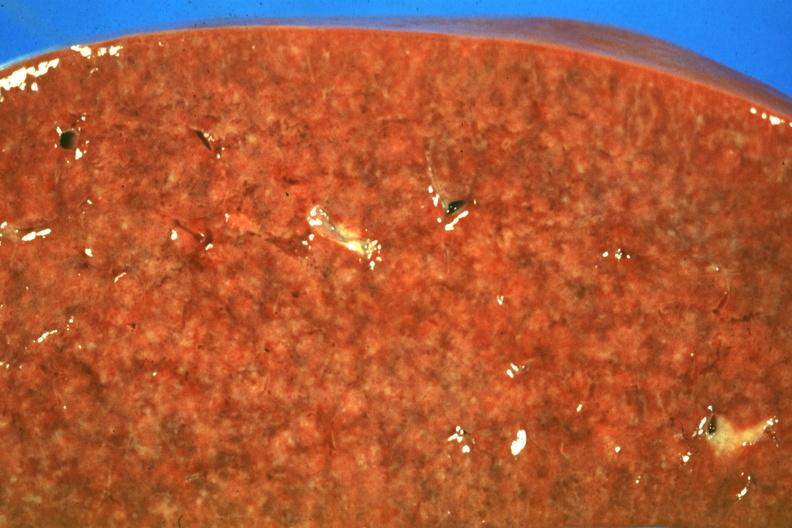what is present?
Answer the question using a single word or phrase. Sarcoidosis 